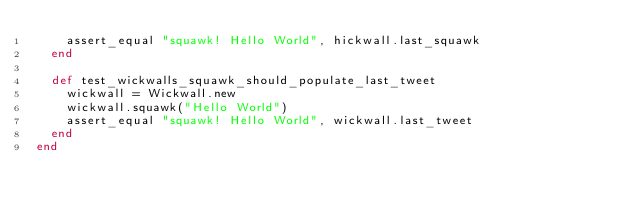Convert code to text. <code><loc_0><loc_0><loc_500><loc_500><_Ruby_>    assert_equal "squawk! Hello World", hickwall.last_squawk
  end

  def test_wickwalls_squawk_should_populate_last_tweet
    wickwall = Wickwall.new
    wickwall.squawk("Hello World")
    assert_equal "squawk! Hello World", wickwall.last_tweet
  end
end</code> 